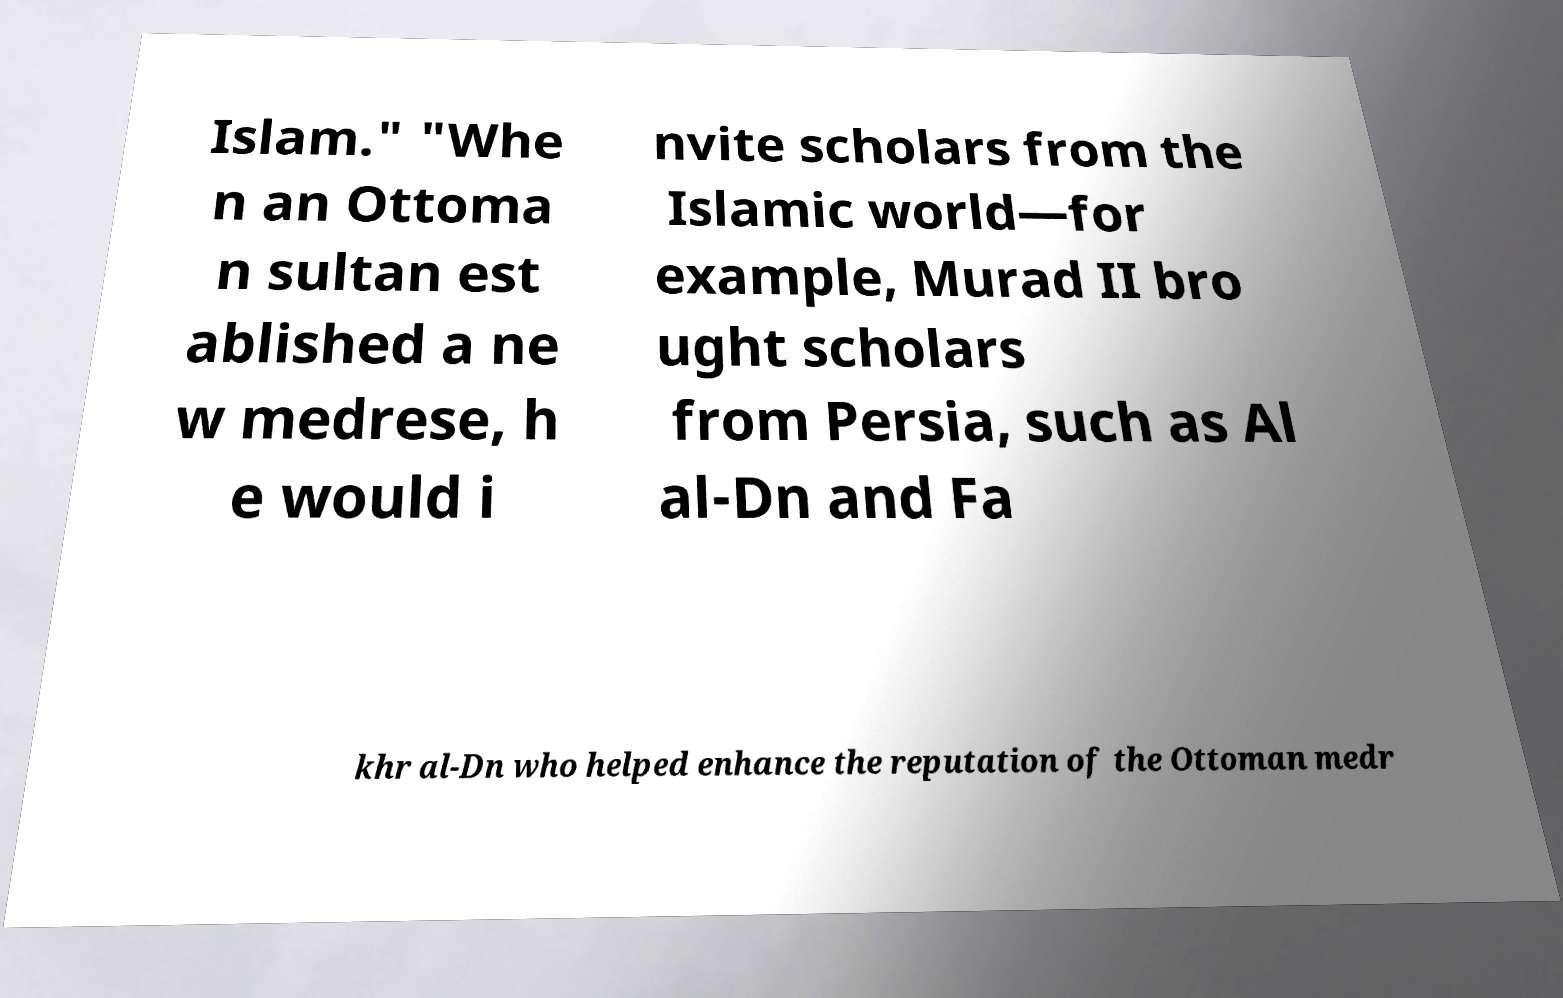Could you assist in decoding the text presented in this image and type it out clearly? Islam." "Whe n an Ottoma n sultan est ablished a ne w medrese, h e would i nvite scholars from the Islamic world—for example, Murad II bro ught scholars from Persia, such as Al al-Dn and Fa khr al-Dn who helped enhance the reputation of the Ottoman medr 